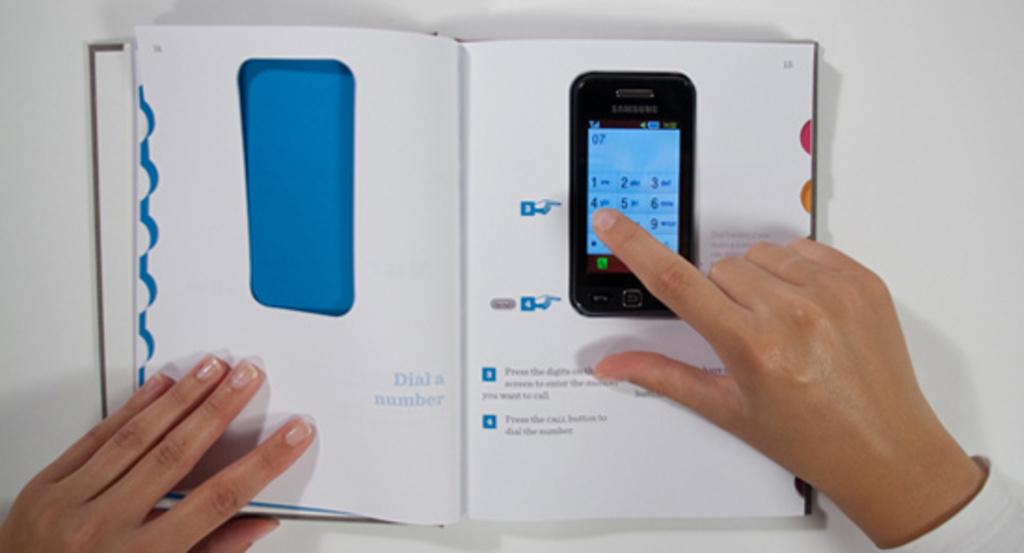<image>
Render a clear and concise summary of the photo. A person has a book open with instructions on hos to use a phone, and has the phone on the book pushing buttons. 